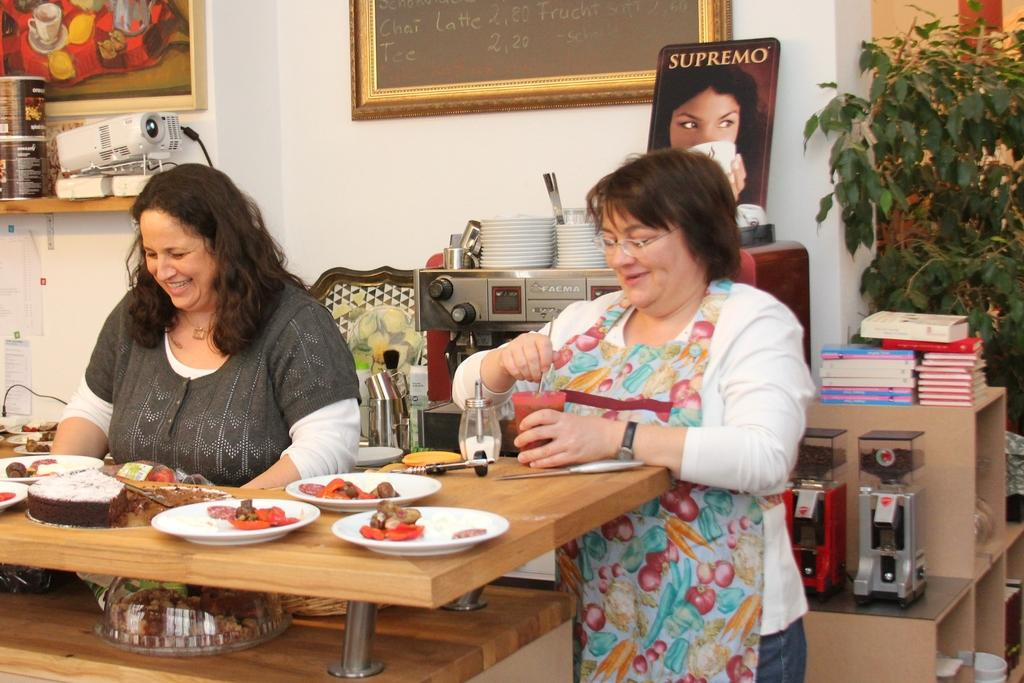How many women are in the image? There are two women in the image. What is on the table in the image? There are food items on a table in the image. What can be seen in the background of the image? There are books, plants, paintings, and a projector in the background of the image. What type of farm can be seen in the image? There is no farm present in the image. What sound does the fan make in the image? There is no fan present in the image, so it is not possible to determine the sound it would make. 